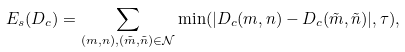Convert formula to latex. <formula><loc_0><loc_0><loc_500><loc_500>E _ { s } ( D _ { c } ) = \sum _ { ( m , n ) , ( \tilde { m } , \tilde { n } ) \in \mathcal { N } } \min ( | D _ { c } ( m , n ) - D _ { c } ( \tilde { m } , \tilde { n } ) | , \tau ) ,</formula> 